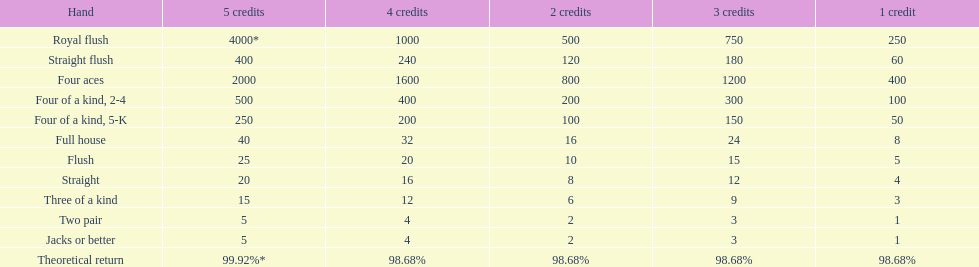What is the aggregate total of a straight flush with 3 credits? 180. 